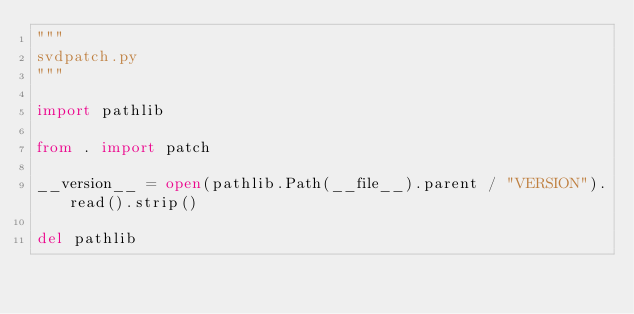Convert code to text. <code><loc_0><loc_0><loc_500><loc_500><_Python_>"""
svdpatch.py
"""

import pathlib

from . import patch

__version__ = open(pathlib.Path(__file__).parent / "VERSION").read().strip()

del pathlib
</code> 